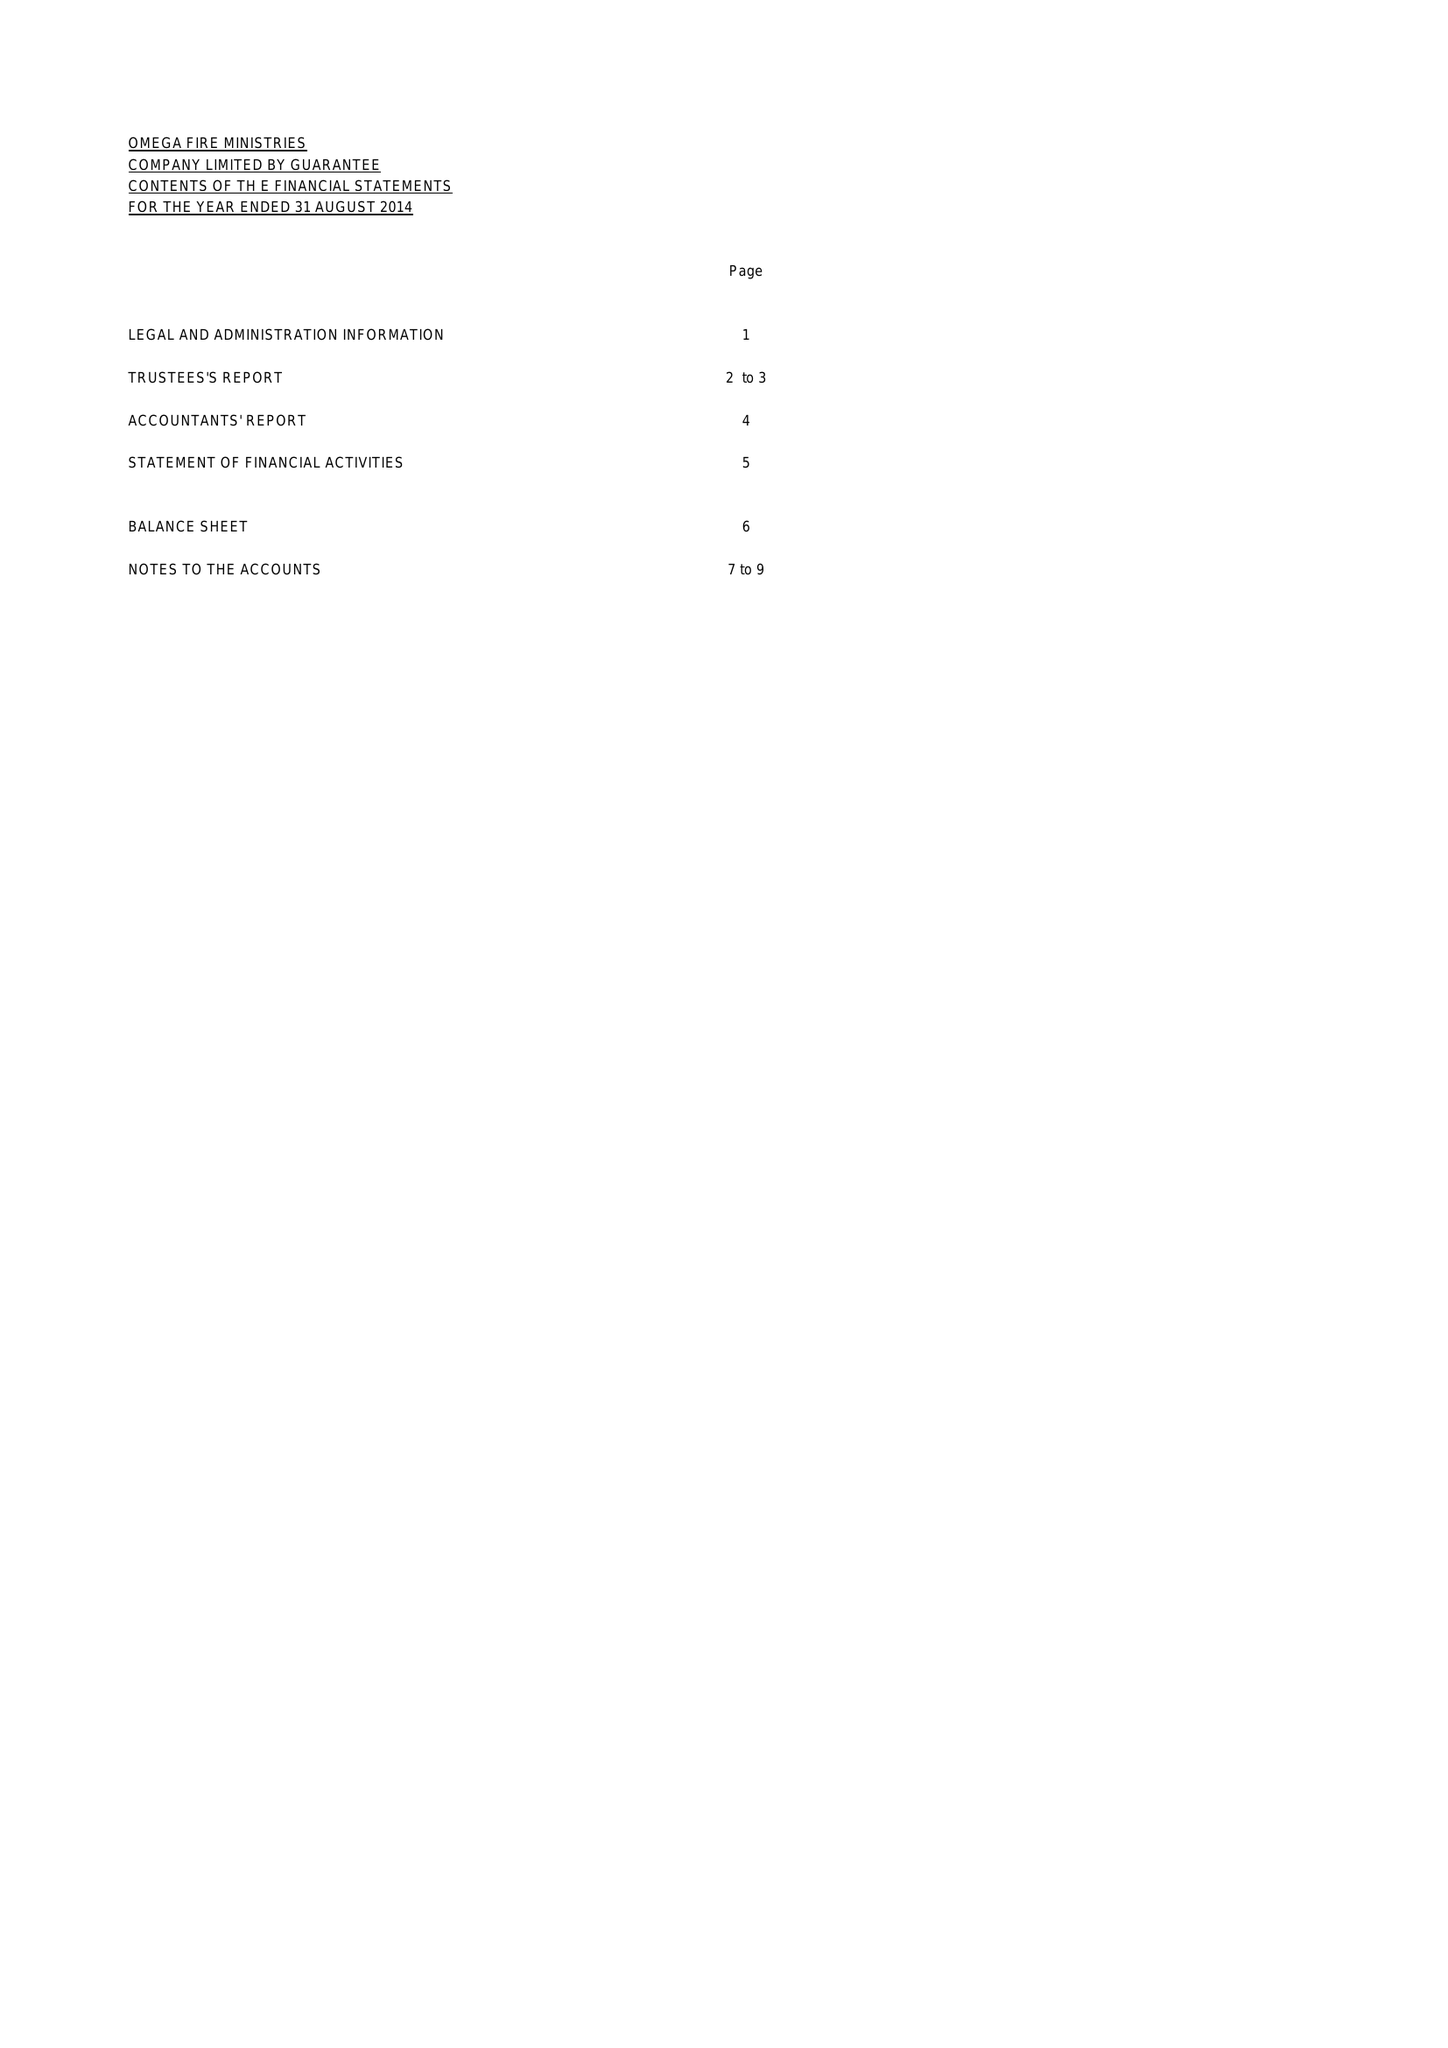What is the value for the charity_number?
Answer the question using a single word or phrase. 1149970 